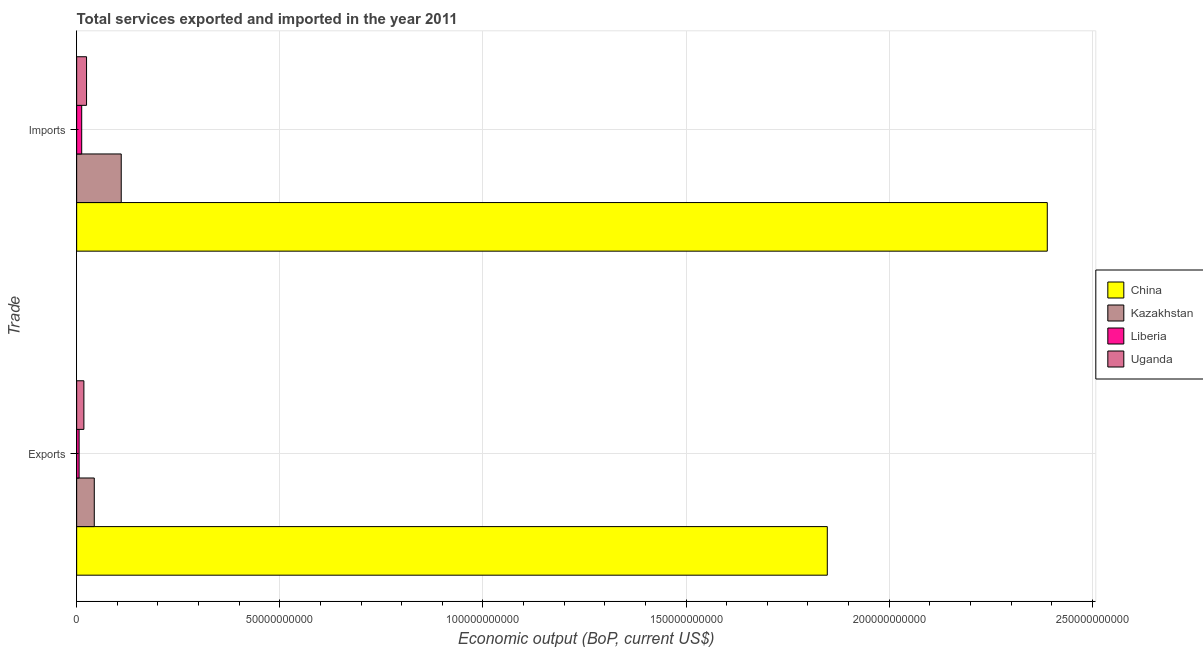How many different coloured bars are there?
Keep it short and to the point. 4. What is the label of the 2nd group of bars from the top?
Give a very brief answer. Exports. What is the amount of service imports in Liberia?
Offer a terse response. 1.24e+09. Across all countries, what is the maximum amount of service exports?
Make the answer very short. 1.85e+11. Across all countries, what is the minimum amount of service exports?
Offer a very short reply. 6.04e+08. In which country was the amount of service imports maximum?
Offer a terse response. China. In which country was the amount of service exports minimum?
Give a very brief answer. Liberia. What is the total amount of service exports in the graph?
Give a very brief answer. 1.91e+11. What is the difference between the amount of service exports in Liberia and that in China?
Offer a very short reply. -1.84e+11. What is the difference between the amount of service exports in Uganda and the amount of service imports in Kazakhstan?
Provide a succinct answer. -9.19e+09. What is the average amount of service imports per country?
Ensure brevity in your answer.  6.34e+1. What is the difference between the amount of service exports and amount of service imports in Uganda?
Keep it short and to the point. -6.55e+08. In how many countries, is the amount of service imports greater than 170000000000 US$?
Offer a terse response. 1. What is the ratio of the amount of service exports in Liberia to that in Uganda?
Your answer should be compact. 0.34. Is the amount of service exports in Kazakhstan less than that in Uganda?
Your answer should be very brief. No. In how many countries, is the amount of service exports greater than the average amount of service exports taken over all countries?
Give a very brief answer. 1. What does the 2nd bar from the top in Exports represents?
Your answer should be compact. Liberia. What does the 1st bar from the bottom in Imports represents?
Make the answer very short. China. How many bars are there?
Ensure brevity in your answer.  8. How many countries are there in the graph?
Make the answer very short. 4. Does the graph contain grids?
Your answer should be very brief. Yes. Where does the legend appear in the graph?
Offer a terse response. Center right. How many legend labels are there?
Make the answer very short. 4. How are the legend labels stacked?
Keep it short and to the point. Vertical. What is the title of the graph?
Make the answer very short. Total services exported and imported in the year 2011. Does "Tanzania" appear as one of the legend labels in the graph?
Give a very brief answer. No. What is the label or title of the X-axis?
Offer a terse response. Economic output (BoP, current US$). What is the label or title of the Y-axis?
Keep it short and to the point. Trade. What is the Economic output (BoP, current US$) in China in Exports?
Provide a short and direct response. 1.85e+11. What is the Economic output (BoP, current US$) in Kazakhstan in Exports?
Your answer should be compact. 4.34e+09. What is the Economic output (BoP, current US$) in Liberia in Exports?
Give a very brief answer. 6.04e+08. What is the Economic output (BoP, current US$) of Uganda in Exports?
Your answer should be compact. 1.78e+09. What is the Economic output (BoP, current US$) in China in Imports?
Your answer should be compact. 2.39e+11. What is the Economic output (BoP, current US$) in Kazakhstan in Imports?
Provide a succinct answer. 1.10e+1. What is the Economic output (BoP, current US$) in Liberia in Imports?
Your response must be concise. 1.24e+09. What is the Economic output (BoP, current US$) of Uganda in Imports?
Keep it short and to the point. 2.43e+09. Across all Trade, what is the maximum Economic output (BoP, current US$) in China?
Offer a very short reply. 2.39e+11. Across all Trade, what is the maximum Economic output (BoP, current US$) of Kazakhstan?
Offer a very short reply. 1.10e+1. Across all Trade, what is the maximum Economic output (BoP, current US$) of Liberia?
Make the answer very short. 1.24e+09. Across all Trade, what is the maximum Economic output (BoP, current US$) in Uganda?
Offer a terse response. 2.43e+09. Across all Trade, what is the minimum Economic output (BoP, current US$) of China?
Provide a succinct answer. 1.85e+11. Across all Trade, what is the minimum Economic output (BoP, current US$) of Kazakhstan?
Keep it short and to the point. 4.34e+09. Across all Trade, what is the minimum Economic output (BoP, current US$) of Liberia?
Keep it short and to the point. 6.04e+08. Across all Trade, what is the minimum Economic output (BoP, current US$) of Uganda?
Provide a short and direct response. 1.78e+09. What is the total Economic output (BoP, current US$) of China in the graph?
Offer a very short reply. 4.24e+11. What is the total Economic output (BoP, current US$) in Kazakhstan in the graph?
Your answer should be very brief. 1.53e+1. What is the total Economic output (BoP, current US$) in Liberia in the graph?
Your answer should be very brief. 1.85e+09. What is the total Economic output (BoP, current US$) in Uganda in the graph?
Make the answer very short. 4.21e+09. What is the difference between the Economic output (BoP, current US$) of China in Exports and that in Imports?
Your answer should be very brief. -5.41e+1. What is the difference between the Economic output (BoP, current US$) of Kazakhstan in Exports and that in Imports?
Your answer should be compact. -6.64e+09. What is the difference between the Economic output (BoP, current US$) of Liberia in Exports and that in Imports?
Keep it short and to the point. -6.39e+08. What is the difference between the Economic output (BoP, current US$) in Uganda in Exports and that in Imports?
Your answer should be very brief. -6.55e+08. What is the difference between the Economic output (BoP, current US$) in China in Exports and the Economic output (BoP, current US$) in Kazakhstan in Imports?
Your answer should be compact. 1.74e+11. What is the difference between the Economic output (BoP, current US$) of China in Exports and the Economic output (BoP, current US$) of Liberia in Imports?
Offer a terse response. 1.84e+11. What is the difference between the Economic output (BoP, current US$) of China in Exports and the Economic output (BoP, current US$) of Uganda in Imports?
Your answer should be compact. 1.82e+11. What is the difference between the Economic output (BoP, current US$) of Kazakhstan in Exports and the Economic output (BoP, current US$) of Liberia in Imports?
Keep it short and to the point. 3.09e+09. What is the difference between the Economic output (BoP, current US$) in Kazakhstan in Exports and the Economic output (BoP, current US$) in Uganda in Imports?
Provide a short and direct response. 1.90e+09. What is the difference between the Economic output (BoP, current US$) of Liberia in Exports and the Economic output (BoP, current US$) of Uganda in Imports?
Your response must be concise. -1.83e+09. What is the average Economic output (BoP, current US$) of China per Trade?
Ensure brevity in your answer.  2.12e+11. What is the average Economic output (BoP, current US$) of Kazakhstan per Trade?
Your answer should be very brief. 7.66e+09. What is the average Economic output (BoP, current US$) of Liberia per Trade?
Provide a succinct answer. 9.23e+08. What is the average Economic output (BoP, current US$) of Uganda per Trade?
Offer a terse response. 2.11e+09. What is the difference between the Economic output (BoP, current US$) in China and Economic output (BoP, current US$) in Kazakhstan in Exports?
Offer a very short reply. 1.80e+11. What is the difference between the Economic output (BoP, current US$) of China and Economic output (BoP, current US$) of Liberia in Exports?
Provide a short and direct response. 1.84e+11. What is the difference between the Economic output (BoP, current US$) of China and Economic output (BoP, current US$) of Uganda in Exports?
Make the answer very short. 1.83e+11. What is the difference between the Economic output (BoP, current US$) in Kazakhstan and Economic output (BoP, current US$) in Liberia in Exports?
Your answer should be compact. 3.73e+09. What is the difference between the Economic output (BoP, current US$) of Kazakhstan and Economic output (BoP, current US$) of Uganda in Exports?
Offer a terse response. 2.56e+09. What is the difference between the Economic output (BoP, current US$) of Liberia and Economic output (BoP, current US$) of Uganda in Exports?
Give a very brief answer. -1.17e+09. What is the difference between the Economic output (BoP, current US$) in China and Economic output (BoP, current US$) in Kazakhstan in Imports?
Provide a succinct answer. 2.28e+11. What is the difference between the Economic output (BoP, current US$) of China and Economic output (BoP, current US$) of Liberia in Imports?
Provide a short and direct response. 2.38e+11. What is the difference between the Economic output (BoP, current US$) in China and Economic output (BoP, current US$) in Uganda in Imports?
Your answer should be compact. 2.36e+11. What is the difference between the Economic output (BoP, current US$) in Kazakhstan and Economic output (BoP, current US$) in Liberia in Imports?
Give a very brief answer. 9.73e+09. What is the difference between the Economic output (BoP, current US$) in Kazakhstan and Economic output (BoP, current US$) in Uganda in Imports?
Keep it short and to the point. 8.54e+09. What is the difference between the Economic output (BoP, current US$) in Liberia and Economic output (BoP, current US$) in Uganda in Imports?
Provide a succinct answer. -1.19e+09. What is the ratio of the Economic output (BoP, current US$) in China in Exports to that in Imports?
Make the answer very short. 0.77. What is the ratio of the Economic output (BoP, current US$) of Kazakhstan in Exports to that in Imports?
Make the answer very short. 0.4. What is the ratio of the Economic output (BoP, current US$) of Liberia in Exports to that in Imports?
Offer a very short reply. 0.49. What is the ratio of the Economic output (BoP, current US$) of Uganda in Exports to that in Imports?
Give a very brief answer. 0.73. What is the difference between the highest and the second highest Economic output (BoP, current US$) in China?
Keep it short and to the point. 5.41e+1. What is the difference between the highest and the second highest Economic output (BoP, current US$) of Kazakhstan?
Offer a very short reply. 6.64e+09. What is the difference between the highest and the second highest Economic output (BoP, current US$) in Liberia?
Your answer should be very brief. 6.39e+08. What is the difference between the highest and the second highest Economic output (BoP, current US$) of Uganda?
Ensure brevity in your answer.  6.55e+08. What is the difference between the highest and the lowest Economic output (BoP, current US$) in China?
Keep it short and to the point. 5.41e+1. What is the difference between the highest and the lowest Economic output (BoP, current US$) in Kazakhstan?
Offer a terse response. 6.64e+09. What is the difference between the highest and the lowest Economic output (BoP, current US$) in Liberia?
Your answer should be compact. 6.39e+08. What is the difference between the highest and the lowest Economic output (BoP, current US$) in Uganda?
Keep it short and to the point. 6.55e+08. 